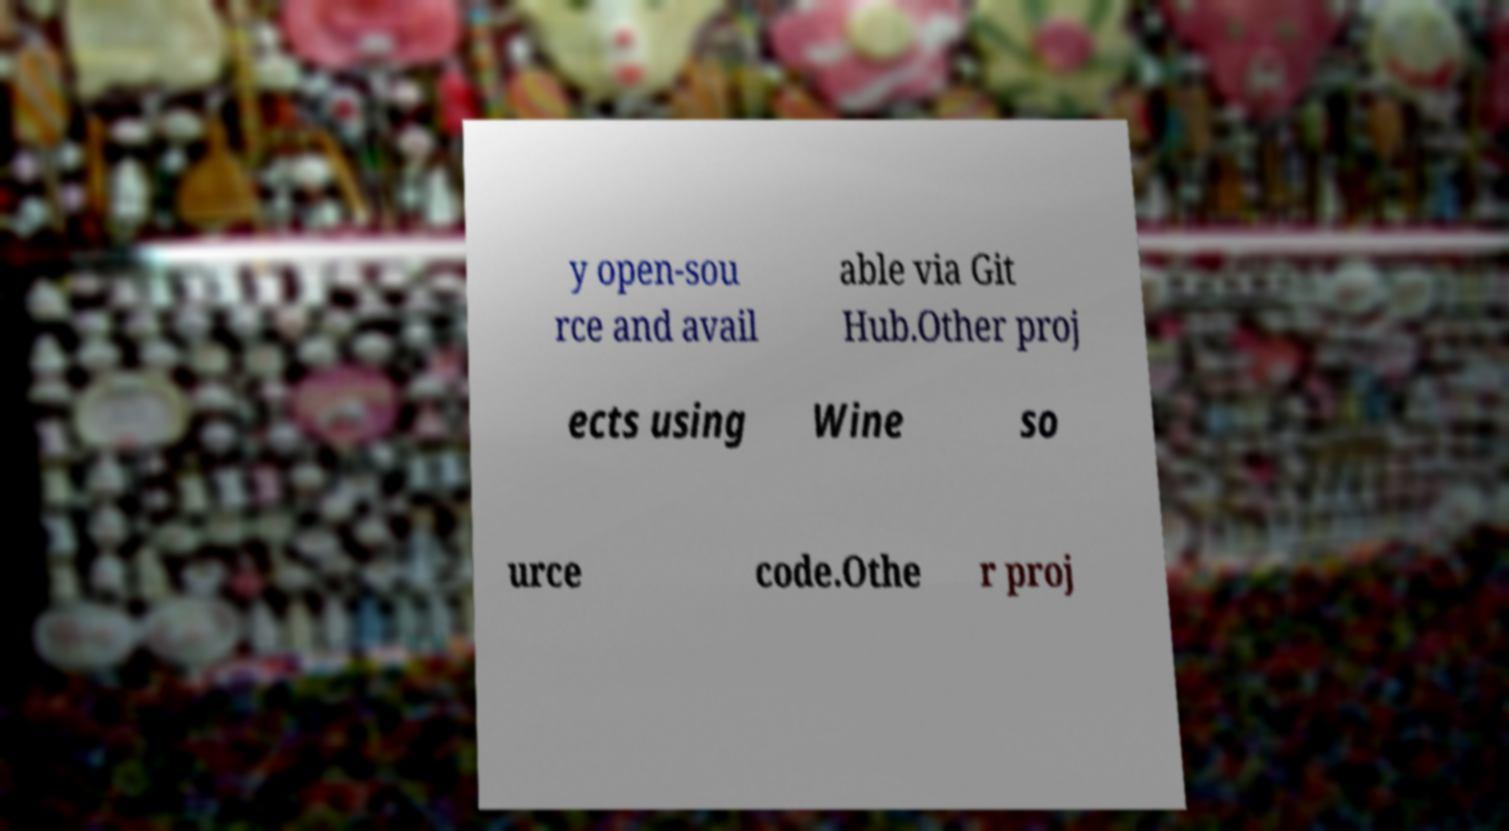Could you assist in decoding the text presented in this image and type it out clearly? y open-sou rce and avail able via Git Hub.Other proj ects using Wine so urce code.Othe r proj 